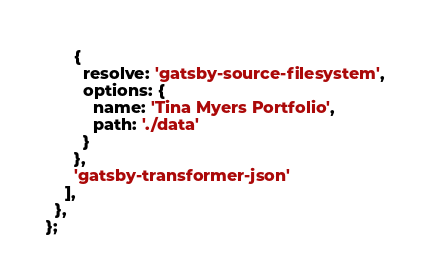Convert code to text. <code><loc_0><loc_0><loc_500><loc_500><_JavaScript_>      {
        resolve: 'gatsby-source-filesystem',
        options: {
          name: 'Tina Myers Portfolio',
          path: './data'
        }
      },
      'gatsby-transformer-json'
    ],
  },
};
</code> 